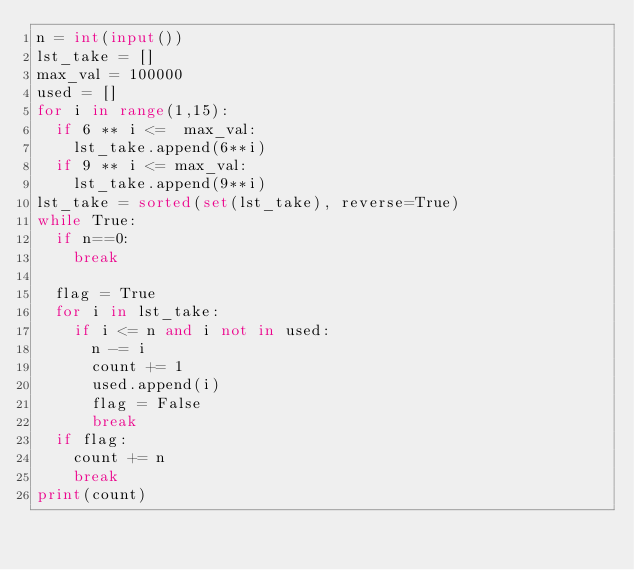<code> <loc_0><loc_0><loc_500><loc_500><_Python_>n = int(input())
lst_take = []
max_val = 100000
used = []
for i in range(1,15):
  if 6 ** i <=  max_val:
    lst_take.append(6**i)
  if 9 ** i <= max_val:
    lst_take.append(9**i)  
lst_take = sorted(set(lst_take), reverse=True)
while True:
  if n==0:
    break
    
  flag = True
  for i in lst_take:
    if i <= n and i not in used:
      n -= i
      count += 1
      used.append(i)
      flag = False
      break
  if flag:
    count += n
    break
print(count)</code> 